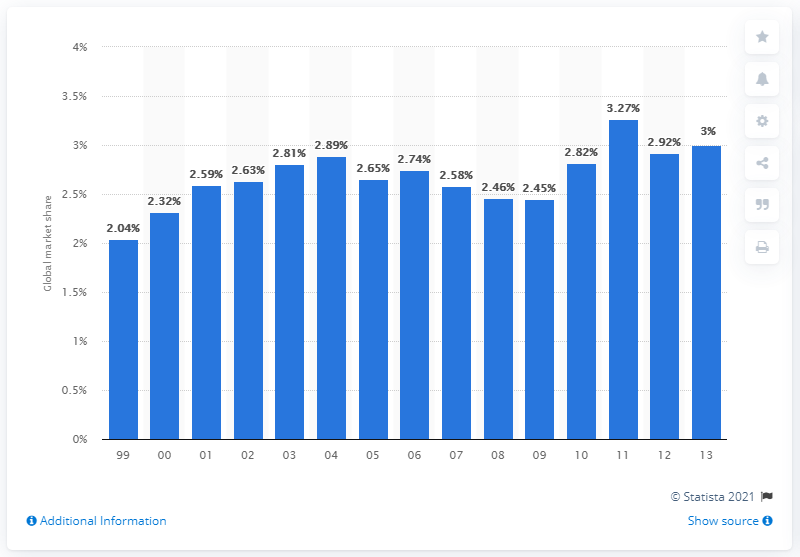Indicate a few pertinent items in this graphic. In 2011, BMW's global market share was 2.82%. 